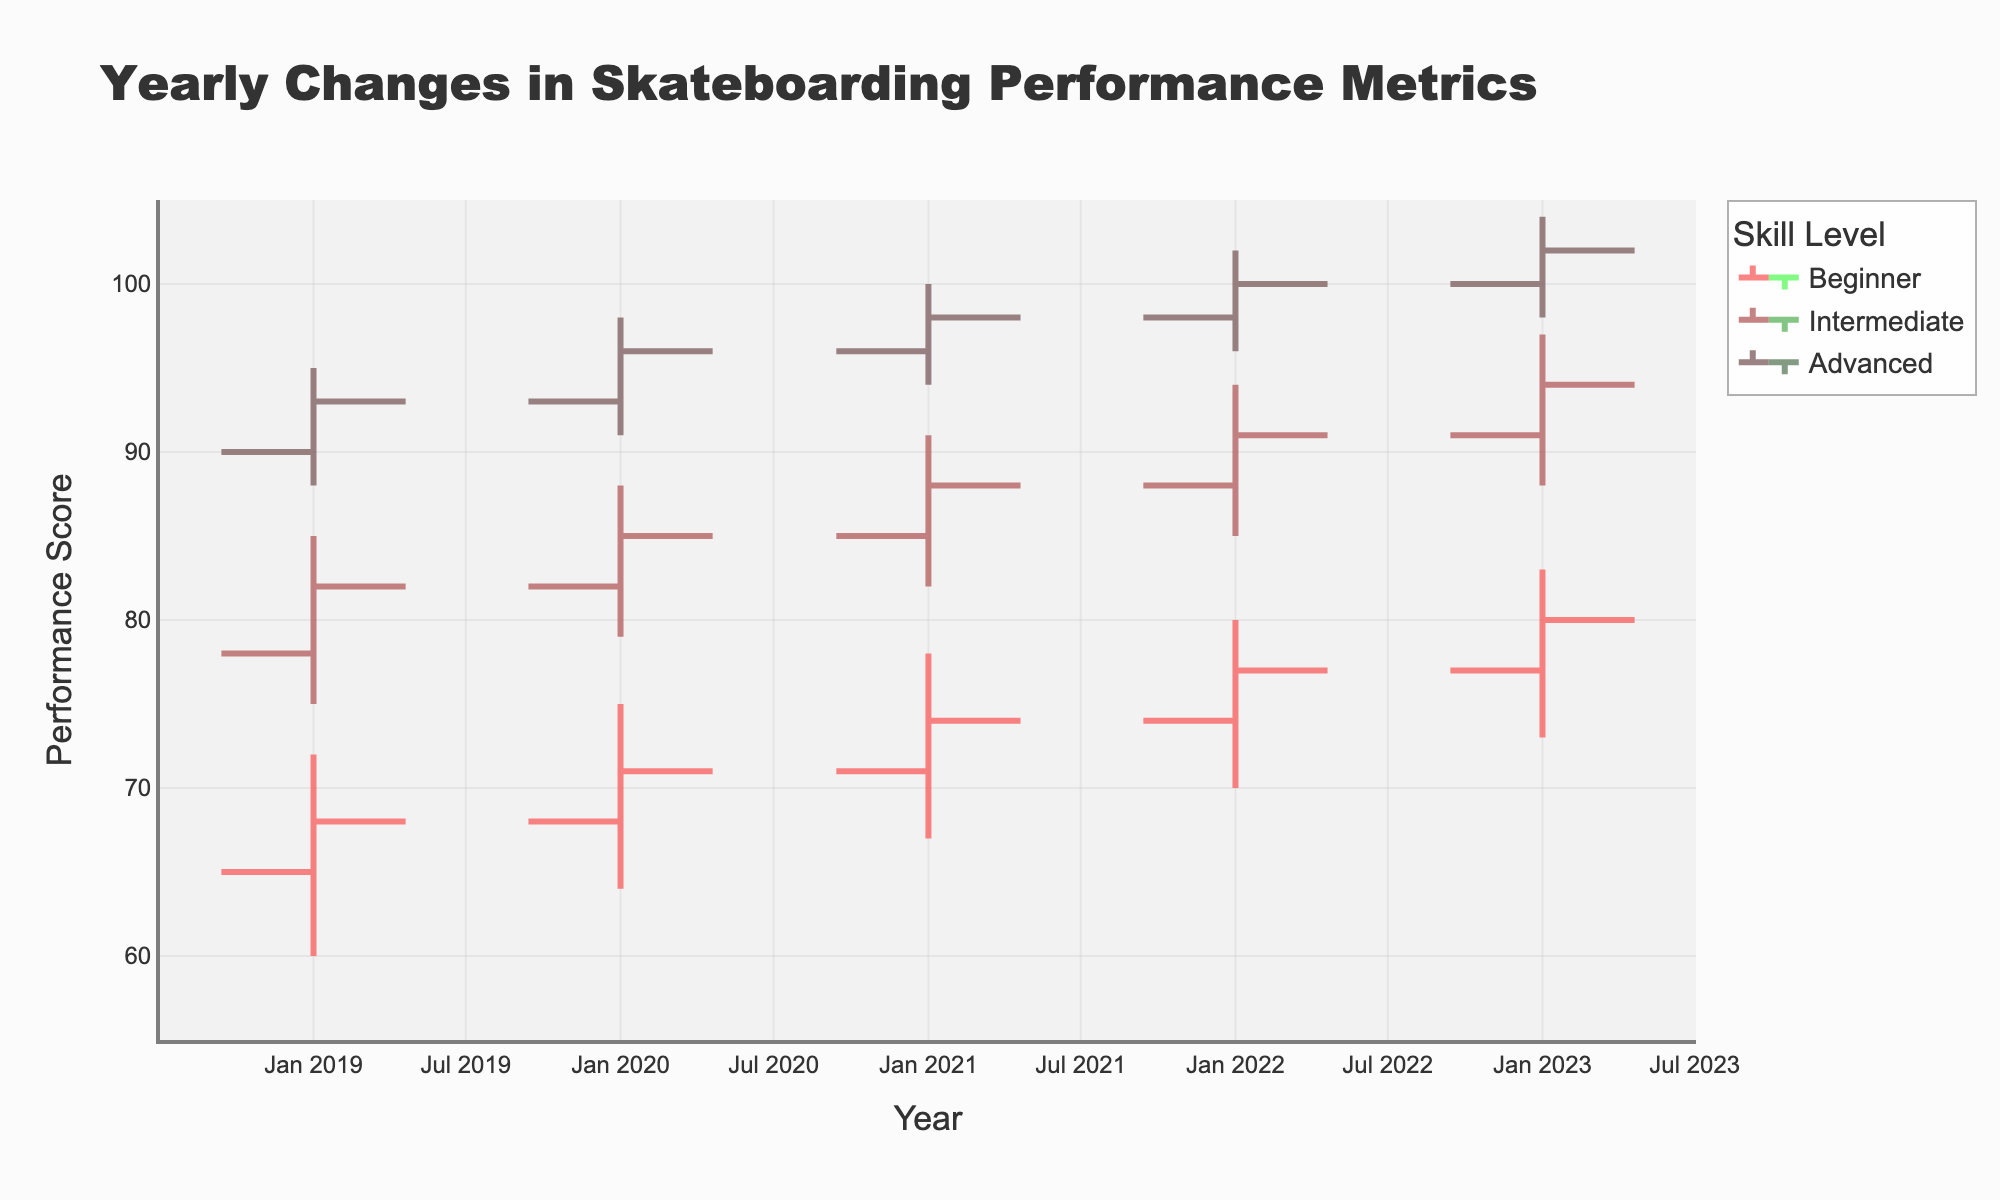What is the title of the chart? The title of a chart is usually prominently displayed at the top. Here, it is "Yearly Changes in Skateboarding Performance Metrics".
Answer: Yearly Changes in Skateboarding Performance Metrics What are the years displayed on the x-axis? The x-axis represents the years for which the data is collected. The plotted years are 2019, 2020, 2021, 2022, and 2023.
Answer: 2019, 2020, 2021, 2022, 2023 What is the y-axis title? The y-axis title indicates the metric that is being measured. Here, it is "Performance Score".
Answer: Performance Score Which skill level shows the highest closing performance score in 2023? The closing performance score for each skill level in 2023 can be observed. For Advanced skill level, it is 102, which is the highest among Beginner (80) and Intermediate (94).
Answer: Advanced Which skill level had the lowest low performance score in 2020? By looking at the 2020 data, the low performance scores are Beginner (64), Intermediate (79), and Advanced (91). The lowest score is for the Beginner skill level.
Answer: Beginner How did the closing performance score for the Beginner skill level change from 2019 to 2020? The closing performance score for Beginner in 2019 was 68, and in 2020 it was 71. Therefore, it increased by 71 - 68 = 3 points.
Answer: Increased by 3 points What was the range of the performance scores for Intermediate skill level in 2021? The range is calculated as the difference between the high and low performance scores. For Intermediate in 2021, the high is 91 and the low is 82. Therefore, the range is 91 - 82 = 9 points.
Answer: 9 points Which skill level shows the smallest increase in closing performance score from 2022 to 2023? By comparing the closing scores for each skill level: 
Beginner: 77 to 80 (3 points increase),
Intermediate: 91 to 94 (3 points increase),
Advanced: 100 to 102 (2 points increase).
The smallest increase is 2 points for Advanced.
Answer: Advanced What is the average closing performance score for the Intermediate skill level from 2019 to 2021? The closing scores for Intermediate from 2019 to 2021 are 82, 85, and 88. The average is (82 + 85 + 88) / 3 = 255 / 3 = 85.
Answer: 85 Which year had the highest high performance score for the Advanced skill level? By comparing the high performance scores for Advanced from 2019 to 2023, 2023 has the highest high score of 104.
Answer: 2023 